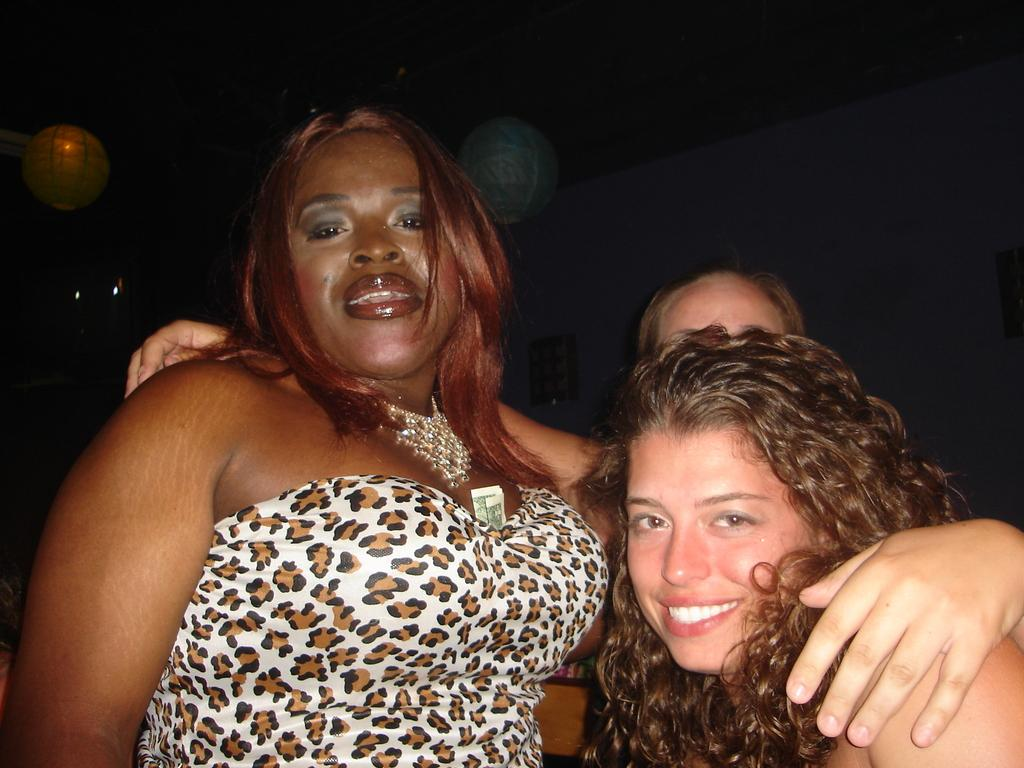How many people are in the image? There are three persons in the image. What is the position of the persons in the image? The persons are standing on the floor. What can be seen in the background of the image? There are lights visible in the background of the image. What type of crayon is being used by one of the persons in the image? There is no crayon present in the image; the persons are standing on the floor with no visible objects in their hands. 